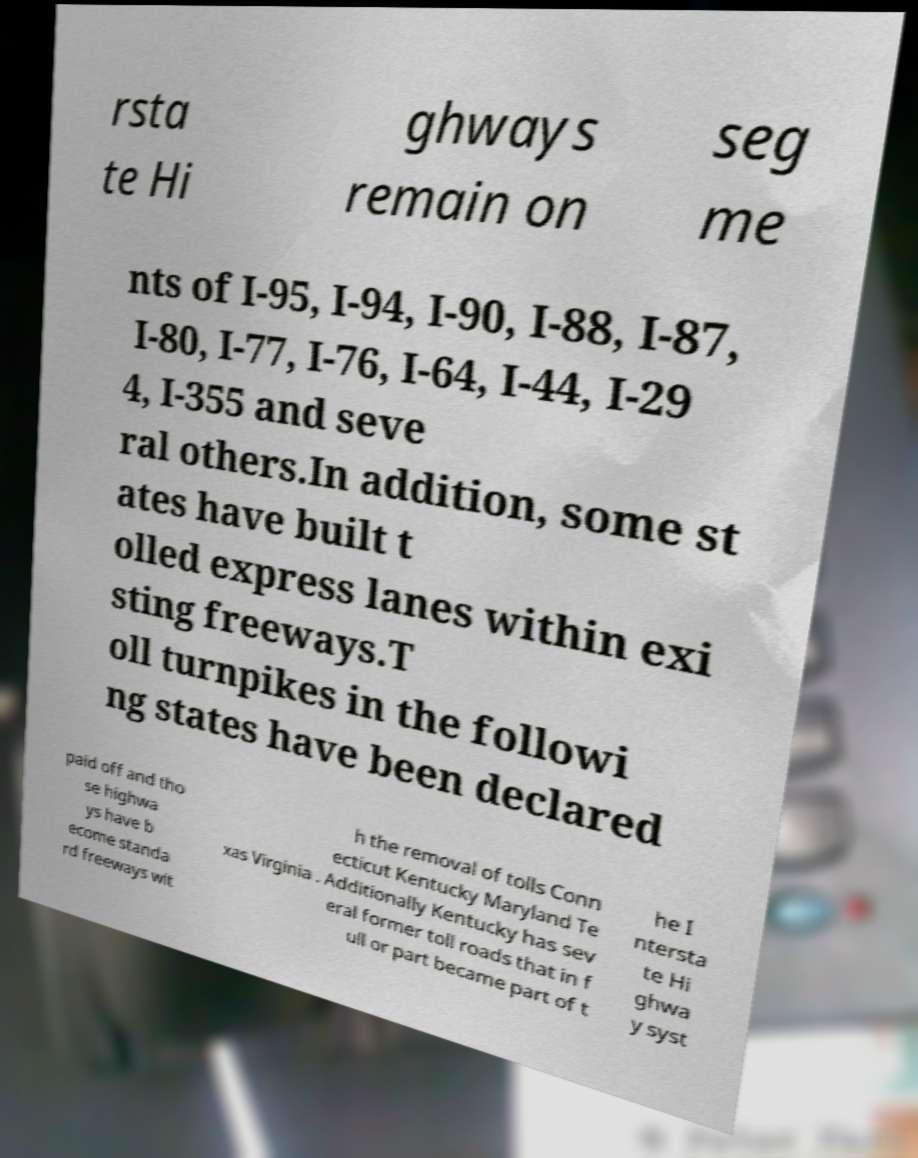What messages or text are displayed in this image? I need them in a readable, typed format. rsta te Hi ghways remain on seg me nts of I-95, I-94, I-90, I-88, I-87, I-80, I-77, I-76, I-64, I-44, I-29 4, I-355 and seve ral others.In addition, some st ates have built t olled express lanes within exi sting freeways.T oll turnpikes in the followi ng states have been declared paid off and tho se highwa ys have b ecome standa rd freeways wit h the removal of tolls Conn ecticut Kentucky Maryland Te xas Virginia . Additionally Kentucky has sev eral former toll roads that in f ull or part became part of t he I ntersta te Hi ghwa y syst 